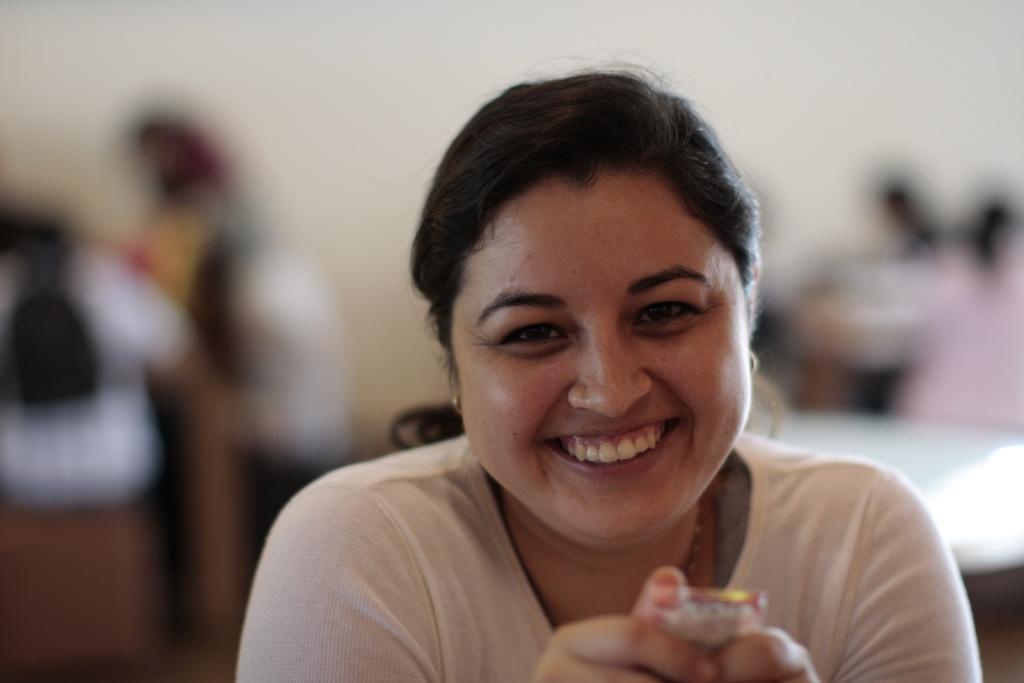Could you give a brief overview of what you see in this image? In the image there is a woman, she is laughing and the background of the woman is blur. 